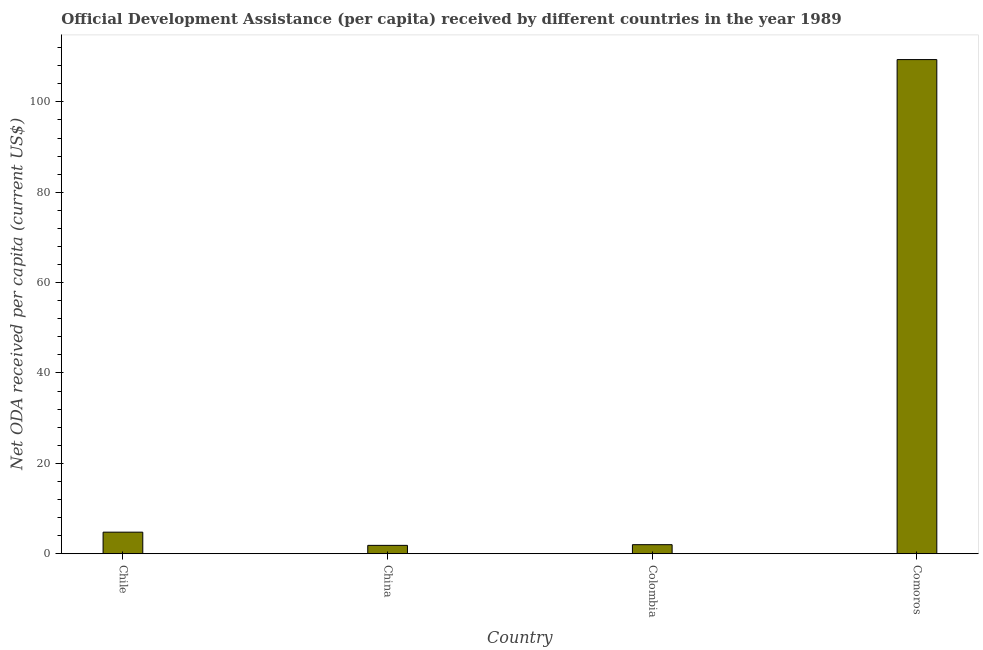Does the graph contain any zero values?
Offer a terse response. No. Does the graph contain grids?
Your answer should be compact. No. What is the title of the graph?
Provide a short and direct response. Official Development Assistance (per capita) received by different countries in the year 1989. What is the label or title of the X-axis?
Ensure brevity in your answer.  Country. What is the label or title of the Y-axis?
Provide a succinct answer. Net ODA received per capita (current US$). What is the net oda received per capita in China?
Make the answer very short. 1.85. Across all countries, what is the maximum net oda received per capita?
Offer a terse response. 109.35. Across all countries, what is the minimum net oda received per capita?
Make the answer very short. 1.85. In which country was the net oda received per capita maximum?
Make the answer very short. Comoros. What is the sum of the net oda received per capita?
Your response must be concise. 117.98. What is the difference between the net oda received per capita in Colombia and Comoros?
Your response must be concise. -107.35. What is the average net oda received per capita per country?
Offer a very short reply. 29.5. What is the median net oda received per capita?
Provide a short and direct response. 3.39. In how many countries, is the net oda received per capita greater than 52 US$?
Offer a terse response. 1. What is the ratio of the net oda received per capita in China to that in Colombia?
Your response must be concise. 0.92. Is the difference between the net oda received per capita in Chile and Comoros greater than the difference between any two countries?
Keep it short and to the point. No. What is the difference between the highest and the second highest net oda received per capita?
Offer a terse response. 104.58. What is the difference between the highest and the lowest net oda received per capita?
Your answer should be very brief. 107.5. In how many countries, is the net oda received per capita greater than the average net oda received per capita taken over all countries?
Your answer should be compact. 1. How many bars are there?
Provide a succinct answer. 4. Are all the bars in the graph horizontal?
Provide a succinct answer. No. How many countries are there in the graph?
Offer a very short reply. 4. Are the values on the major ticks of Y-axis written in scientific E-notation?
Make the answer very short. No. What is the Net ODA received per capita (current US$) in Chile?
Keep it short and to the point. 4.77. What is the Net ODA received per capita (current US$) of China?
Your answer should be very brief. 1.85. What is the Net ODA received per capita (current US$) in Colombia?
Offer a very short reply. 2. What is the Net ODA received per capita (current US$) of Comoros?
Give a very brief answer. 109.35. What is the difference between the Net ODA received per capita (current US$) in Chile and China?
Keep it short and to the point. 2.92. What is the difference between the Net ODA received per capita (current US$) in Chile and Colombia?
Ensure brevity in your answer.  2.77. What is the difference between the Net ODA received per capita (current US$) in Chile and Comoros?
Ensure brevity in your answer.  -104.58. What is the difference between the Net ODA received per capita (current US$) in China and Colombia?
Keep it short and to the point. -0.15. What is the difference between the Net ODA received per capita (current US$) in China and Comoros?
Keep it short and to the point. -107.5. What is the difference between the Net ODA received per capita (current US$) in Colombia and Comoros?
Your answer should be very brief. -107.35. What is the ratio of the Net ODA received per capita (current US$) in Chile to that in China?
Offer a very short reply. 2.58. What is the ratio of the Net ODA received per capita (current US$) in Chile to that in Colombia?
Offer a very short reply. 2.38. What is the ratio of the Net ODA received per capita (current US$) in Chile to that in Comoros?
Provide a short and direct response. 0.04. What is the ratio of the Net ODA received per capita (current US$) in China to that in Colombia?
Your response must be concise. 0.92. What is the ratio of the Net ODA received per capita (current US$) in China to that in Comoros?
Keep it short and to the point. 0.02. What is the ratio of the Net ODA received per capita (current US$) in Colombia to that in Comoros?
Give a very brief answer. 0.02. 